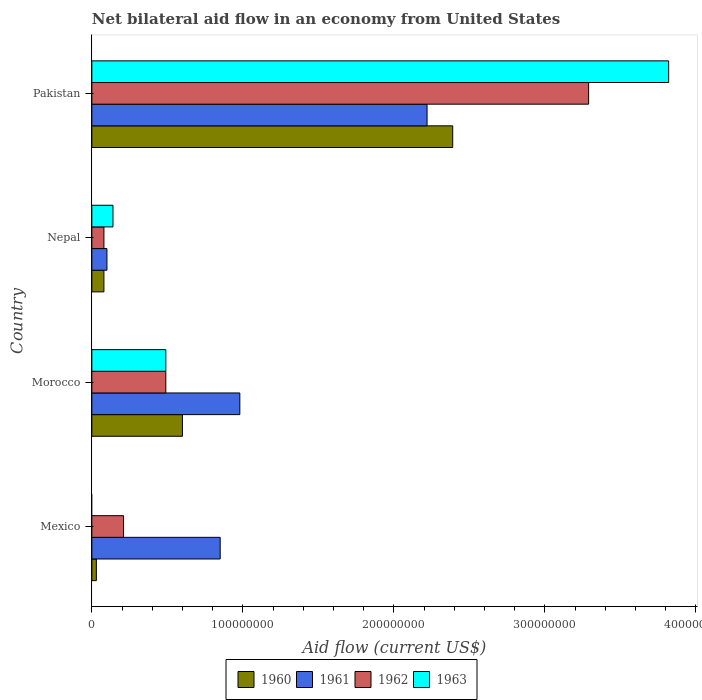How many different coloured bars are there?
Provide a succinct answer. 4. How many bars are there on the 3rd tick from the top?
Your answer should be compact. 4. What is the label of the 2nd group of bars from the top?
Your answer should be very brief. Nepal. In how many cases, is the number of bars for a given country not equal to the number of legend labels?
Your answer should be compact. 1. Across all countries, what is the maximum net bilateral aid flow in 1963?
Provide a short and direct response. 3.82e+08. Across all countries, what is the minimum net bilateral aid flow in 1961?
Keep it short and to the point. 1.00e+07. What is the total net bilateral aid flow in 1961 in the graph?
Provide a short and direct response. 4.15e+08. What is the difference between the net bilateral aid flow in 1960 in Morocco and that in Pakistan?
Your answer should be very brief. -1.79e+08. What is the difference between the net bilateral aid flow in 1960 in Morocco and the net bilateral aid flow in 1962 in Mexico?
Provide a succinct answer. 3.90e+07. What is the average net bilateral aid flow in 1963 per country?
Provide a succinct answer. 1.11e+08. What is the difference between the net bilateral aid flow in 1960 and net bilateral aid flow in 1962 in Morocco?
Give a very brief answer. 1.10e+07. What is the ratio of the net bilateral aid flow in 1962 in Morocco to that in Nepal?
Offer a very short reply. 6.12. What is the difference between the highest and the second highest net bilateral aid flow in 1960?
Your response must be concise. 1.79e+08. What is the difference between the highest and the lowest net bilateral aid flow in 1962?
Provide a succinct answer. 3.21e+08. In how many countries, is the net bilateral aid flow in 1960 greater than the average net bilateral aid flow in 1960 taken over all countries?
Make the answer very short. 1. Is it the case that in every country, the sum of the net bilateral aid flow in 1961 and net bilateral aid flow in 1960 is greater than the sum of net bilateral aid flow in 1963 and net bilateral aid flow in 1962?
Ensure brevity in your answer.  No. Is it the case that in every country, the sum of the net bilateral aid flow in 1963 and net bilateral aid flow in 1961 is greater than the net bilateral aid flow in 1960?
Provide a short and direct response. Yes. How many countries are there in the graph?
Provide a succinct answer. 4. Are the values on the major ticks of X-axis written in scientific E-notation?
Offer a terse response. No. Does the graph contain grids?
Keep it short and to the point. No. How many legend labels are there?
Keep it short and to the point. 4. How are the legend labels stacked?
Your response must be concise. Horizontal. What is the title of the graph?
Offer a very short reply. Net bilateral aid flow in an economy from United States. What is the label or title of the Y-axis?
Make the answer very short. Country. What is the Aid flow (current US$) of 1961 in Mexico?
Make the answer very short. 8.50e+07. What is the Aid flow (current US$) of 1962 in Mexico?
Keep it short and to the point. 2.10e+07. What is the Aid flow (current US$) of 1963 in Mexico?
Ensure brevity in your answer.  0. What is the Aid flow (current US$) of 1960 in Morocco?
Make the answer very short. 6.00e+07. What is the Aid flow (current US$) of 1961 in Morocco?
Give a very brief answer. 9.80e+07. What is the Aid flow (current US$) in 1962 in Morocco?
Offer a very short reply. 4.90e+07. What is the Aid flow (current US$) in 1963 in Morocco?
Provide a succinct answer. 4.90e+07. What is the Aid flow (current US$) of 1960 in Nepal?
Provide a short and direct response. 8.00e+06. What is the Aid flow (current US$) of 1961 in Nepal?
Provide a short and direct response. 1.00e+07. What is the Aid flow (current US$) in 1962 in Nepal?
Keep it short and to the point. 8.00e+06. What is the Aid flow (current US$) in 1963 in Nepal?
Ensure brevity in your answer.  1.40e+07. What is the Aid flow (current US$) of 1960 in Pakistan?
Your answer should be very brief. 2.39e+08. What is the Aid flow (current US$) of 1961 in Pakistan?
Your answer should be compact. 2.22e+08. What is the Aid flow (current US$) of 1962 in Pakistan?
Ensure brevity in your answer.  3.29e+08. What is the Aid flow (current US$) of 1963 in Pakistan?
Provide a succinct answer. 3.82e+08. Across all countries, what is the maximum Aid flow (current US$) of 1960?
Your answer should be very brief. 2.39e+08. Across all countries, what is the maximum Aid flow (current US$) of 1961?
Give a very brief answer. 2.22e+08. Across all countries, what is the maximum Aid flow (current US$) in 1962?
Provide a short and direct response. 3.29e+08. Across all countries, what is the maximum Aid flow (current US$) of 1963?
Your answer should be very brief. 3.82e+08. Across all countries, what is the minimum Aid flow (current US$) in 1961?
Give a very brief answer. 1.00e+07. What is the total Aid flow (current US$) of 1960 in the graph?
Your response must be concise. 3.10e+08. What is the total Aid flow (current US$) of 1961 in the graph?
Give a very brief answer. 4.15e+08. What is the total Aid flow (current US$) in 1962 in the graph?
Your answer should be very brief. 4.07e+08. What is the total Aid flow (current US$) of 1963 in the graph?
Provide a short and direct response. 4.45e+08. What is the difference between the Aid flow (current US$) of 1960 in Mexico and that in Morocco?
Ensure brevity in your answer.  -5.70e+07. What is the difference between the Aid flow (current US$) in 1961 in Mexico and that in Morocco?
Provide a succinct answer. -1.30e+07. What is the difference between the Aid flow (current US$) of 1962 in Mexico and that in Morocco?
Your answer should be compact. -2.80e+07. What is the difference between the Aid flow (current US$) in 1960 in Mexico and that in Nepal?
Your answer should be compact. -5.00e+06. What is the difference between the Aid flow (current US$) of 1961 in Mexico and that in Nepal?
Your answer should be very brief. 7.50e+07. What is the difference between the Aid flow (current US$) of 1962 in Mexico and that in Nepal?
Make the answer very short. 1.30e+07. What is the difference between the Aid flow (current US$) in 1960 in Mexico and that in Pakistan?
Provide a short and direct response. -2.36e+08. What is the difference between the Aid flow (current US$) in 1961 in Mexico and that in Pakistan?
Your answer should be compact. -1.37e+08. What is the difference between the Aid flow (current US$) in 1962 in Mexico and that in Pakistan?
Your answer should be very brief. -3.08e+08. What is the difference between the Aid flow (current US$) in 1960 in Morocco and that in Nepal?
Offer a terse response. 5.20e+07. What is the difference between the Aid flow (current US$) of 1961 in Morocco and that in Nepal?
Provide a short and direct response. 8.80e+07. What is the difference between the Aid flow (current US$) in 1962 in Morocco and that in Nepal?
Your response must be concise. 4.10e+07. What is the difference between the Aid flow (current US$) of 1963 in Morocco and that in Nepal?
Offer a terse response. 3.50e+07. What is the difference between the Aid flow (current US$) in 1960 in Morocco and that in Pakistan?
Give a very brief answer. -1.79e+08. What is the difference between the Aid flow (current US$) of 1961 in Morocco and that in Pakistan?
Offer a very short reply. -1.24e+08. What is the difference between the Aid flow (current US$) of 1962 in Morocco and that in Pakistan?
Ensure brevity in your answer.  -2.80e+08. What is the difference between the Aid flow (current US$) of 1963 in Morocco and that in Pakistan?
Make the answer very short. -3.33e+08. What is the difference between the Aid flow (current US$) in 1960 in Nepal and that in Pakistan?
Your answer should be compact. -2.31e+08. What is the difference between the Aid flow (current US$) of 1961 in Nepal and that in Pakistan?
Your answer should be compact. -2.12e+08. What is the difference between the Aid flow (current US$) in 1962 in Nepal and that in Pakistan?
Provide a succinct answer. -3.21e+08. What is the difference between the Aid flow (current US$) of 1963 in Nepal and that in Pakistan?
Your answer should be compact. -3.68e+08. What is the difference between the Aid flow (current US$) in 1960 in Mexico and the Aid flow (current US$) in 1961 in Morocco?
Your response must be concise. -9.50e+07. What is the difference between the Aid flow (current US$) of 1960 in Mexico and the Aid flow (current US$) of 1962 in Morocco?
Your answer should be compact. -4.60e+07. What is the difference between the Aid flow (current US$) in 1960 in Mexico and the Aid flow (current US$) in 1963 in Morocco?
Ensure brevity in your answer.  -4.60e+07. What is the difference between the Aid flow (current US$) of 1961 in Mexico and the Aid flow (current US$) of 1962 in Morocco?
Ensure brevity in your answer.  3.60e+07. What is the difference between the Aid flow (current US$) of 1961 in Mexico and the Aid flow (current US$) of 1963 in Morocco?
Ensure brevity in your answer.  3.60e+07. What is the difference between the Aid flow (current US$) in 1962 in Mexico and the Aid flow (current US$) in 1963 in Morocco?
Make the answer very short. -2.80e+07. What is the difference between the Aid flow (current US$) of 1960 in Mexico and the Aid flow (current US$) of 1961 in Nepal?
Keep it short and to the point. -7.00e+06. What is the difference between the Aid flow (current US$) in 1960 in Mexico and the Aid flow (current US$) in 1962 in Nepal?
Give a very brief answer. -5.00e+06. What is the difference between the Aid flow (current US$) in 1960 in Mexico and the Aid flow (current US$) in 1963 in Nepal?
Ensure brevity in your answer.  -1.10e+07. What is the difference between the Aid flow (current US$) in 1961 in Mexico and the Aid flow (current US$) in 1962 in Nepal?
Your answer should be compact. 7.70e+07. What is the difference between the Aid flow (current US$) of 1961 in Mexico and the Aid flow (current US$) of 1963 in Nepal?
Ensure brevity in your answer.  7.10e+07. What is the difference between the Aid flow (current US$) in 1960 in Mexico and the Aid flow (current US$) in 1961 in Pakistan?
Keep it short and to the point. -2.19e+08. What is the difference between the Aid flow (current US$) in 1960 in Mexico and the Aid flow (current US$) in 1962 in Pakistan?
Your response must be concise. -3.26e+08. What is the difference between the Aid flow (current US$) of 1960 in Mexico and the Aid flow (current US$) of 1963 in Pakistan?
Make the answer very short. -3.79e+08. What is the difference between the Aid flow (current US$) of 1961 in Mexico and the Aid flow (current US$) of 1962 in Pakistan?
Keep it short and to the point. -2.44e+08. What is the difference between the Aid flow (current US$) of 1961 in Mexico and the Aid flow (current US$) of 1963 in Pakistan?
Ensure brevity in your answer.  -2.97e+08. What is the difference between the Aid flow (current US$) of 1962 in Mexico and the Aid flow (current US$) of 1963 in Pakistan?
Provide a short and direct response. -3.61e+08. What is the difference between the Aid flow (current US$) in 1960 in Morocco and the Aid flow (current US$) in 1962 in Nepal?
Provide a short and direct response. 5.20e+07. What is the difference between the Aid flow (current US$) of 1960 in Morocco and the Aid flow (current US$) of 1963 in Nepal?
Provide a short and direct response. 4.60e+07. What is the difference between the Aid flow (current US$) in 1961 in Morocco and the Aid flow (current US$) in 1962 in Nepal?
Provide a succinct answer. 9.00e+07. What is the difference between the Aid flow (current US$) of 1961 in Morocco and the Aid flow (current US$) of 1963 in Nepal?
Give a very brief answer. 8.40e+07. What is the difference between the Aid flow (current US$) of 1962 in Morocco and the Aid flow (current US$) of 1963 in Nepal?
Offer a very short reply. 3.50e+07. What is the difference between the Aid flow (current US$) of 1960 in Morocco and the Aid flow (current US$) of 1961 in Pakistan?
Provide a short and direct response. -1.62e+08. What is the difference between the Aid flow (current US$) in 1960 in Morocco and the Aid flow (current US$) in 1962 in Pakistan?
Your response must be concise. -2.69e+08. What is the difference between the Aid flow (current US$) of 1960 in Morocco and the Aid flow (current US$) of 1963 in Pakistan?
Offer a terse response. -3.22e+08. What is the difference between the Aid flow (current US$) in 1961 in Morocco and the Aid flow (current US$) in 1962 in Pakistan?
Provide a short and direct response. -2.31e+08. What is the difference between the Aid flow (current US$) in 1961 in Morocco and the Aid flow (current US$) in 1963 in Pakistan?
Keep it short and to the point. -2.84e+08. What is the difference between the Aid flow (current US$) of 1962 in Morocco and the Aid flow (current US$) of 1963 in Pakistan?
Keep it short and to the point. -3.33e+08. What is the difference between the Aid flow (current US$) of 1960 in Nepal and the Aid flow (current US$) of 1961 in Pakistan?
Give a very brief answer. -2.14e+08. What is the difference between the Aid flow (current US$) in 1960 in Nepal and the Aid flow (current US$) in 1962 in Pakistan?
Make the answer very short. -3.21e+08. What is the difference between the Aid flow (current US$) of 1960 in Nepal and the Aid flow (current US$) of 1963 in Pakistan?
Make the answer very short. -3.74e+08. What is the difference between the Aid flow (current US$) of 1961 in Nepal and the Aid flow (current US$) of 1962 in Pakistan?
Offer a terse response. -3.19e+08. What is the difference between the Aid flow (current US$) in 1961 in Nepal and the Aid flow (current US$) in 1963 in Pakistan?
Offer a very short reply. -3.72e+08. What is the difference between the Aid flow (current US$) in 1962 in Nepal and the Aid flow (current US$) in 1963 in Pakistan?
Provide a succinct answer. -3.74e+08. What is the average Aid flow (current US$) in 1960 per country?
Your answer should be compact. 7.75e+07. What is the average Aid flow (current US$) of 1961 per country?
Offer a terse response. 1.04e+08. What is the average Aid flow (current US$) of 1962 per country?
Offer a very short reply. 1.02e+08. What is the average Aid flow (current US$) in 1963 per country?
Provide a short and direct response. 1.11e+08. What is the difference between the Aid flow (current US$) in 1960 and Aid flow (current US$) in 1961 in Mexico?
Your response must be concise. -8.20e+07. What is the difference between the Aid flow (current US$) of 1960 and Aid flow (current US$) of 1962 in Mexico?
Offer a very short reply. -1.80e+07. What is the difference between the Aid flow (current US$) of 1961 and Aid flow (current US$) of 1962 in Mexico?
Your response must be concise. 6.40e+07. What is the difference between the Aid flow (current US$) in 1960 and Aid flow (current US$) in 1961 in Morocco?
Give a very brief answer. -3.80e+07. What is the difference between the Aid flow (current US$) of 1960 and Aid flow (current US$) of 1962 in Morocco?
Keep it short and to the point. 1.10e+07. What is the difference between the Aid flow (current US$) in 1960 and Aid flow (current US$) in 1963 in Morocco?
Give a very brief answer. 1.10e+07. What is the difference between the Aid flow (current US$) in 1961 and Aid flow (current US$) in 1962 in Morocco?
Ensure brevity in your answer.  4.90e+07. What is the difference between the Aid flow (current US$) of 1961 and Aid flow (current US$) of 1963 in Morocco?
Offer a very short reply. 4.90e+07. What is the difference between the Aid flow (current US$) in 1962 and Aid flow (current US$) in 1963 in Morocco?
Ensure brevity in your answer.  0. What is the difference between the Aid flow (current US$) in 1960 and Aid flow (current US$) in 1961 in Nepal?
Offer a very short reply. -2.00e+06. What is the difference between the Aid flow (current US$) of 1960 and Aid flow (current US$) of 1962 in Nepal?
Your answer should be very brief. 0. What is the difference between the Aid flow (current US$) in 1960 and Aid flow (current US$) in 1963 in Nepal?
Your response must be concise. -6.00e+06. What is the difference between the Aid flow (current US$) in 1961 and Aid flow (current US$) in 1962 in Nepal?
Offer a terse response. 2.00e+06. What is the difference between the Aid flow (current US$) in 1961 and Aid flow (current US$) in 1963 in Nepal?
Make the answer very short. -4.00e+06. What is the difference between the Aid flow (current US$) in 1962 and Aid flow (current US$) in 1963 in Nepal?
Give a very brief answer. -6.00e+06. What is the difference between the Aid flow (current US$) of 1960 and Aid flow (current US$) of 1961 in Pakistan?
Make the answer very short. 1.70e+07. What is the difference between the Aid flow (current US$) in 1960 and Aid flow (current US$) in 1962 in Pakistan?
Provide a succinct answer. -9.00e+07. What is the difference between the Aid flow (current US$) in 1960 and Aid flow (current US$) in 1963 in Pakistan?
Provide a short and direct response. -1.43e+08. What is the difference between the Aid flow (current US$) of 1961 and Aid flow (current US$) of 1962 in Pakistan?
Ensure brevity in your answer.  -1.07e+08. What is the difference between the Aid flow (current US$) in 1961 and Aid flow (current US$) in 1963 in Pakistan?
Offer a very short reply. -1.60e+08. What is the difference between the Aid flow (current US$) of 1962 and Aid flow (current US$) of 1963 in Pakistan?
Ensure brevity in your answer.  -5.30e+07. What is the ratio of the Aid flow (current US$) of 1960 in Mexico to that in Morocco?
Provide a short and direct response. 0.05. What is the ratio of the Aid flow (current US$) of 1961 in Mexico to that in Morocco?
Your answer should be very brief. 0.87. What is the ratio of the Aid flow (current US$) in 1962 in Mexico to that in Morocco?
Give a very brief answer. 0.43. What is the ratio of the Aid flow (current US$) of 1962 in Mexico to that in Nepal?
Offer a very short reply. 2.62. What is the ratio of the Aid flow (current US$) of 1960 in Mexico to that in Pakistan?
Offer a terse response. 0.01. What is the ratio of the Aid flow (current US$) of 1961 in Mexico to that in Pakistan?
Your answer should be compact. 0.38. What is the ratio of the Aid flow (current US$) in 1962 in Mexico to that in Pakistan?
Provide a succinct answer. 0.06. What is the ratio of the Aid flow (current US$) in 1962 in Morocco to that in Nepal?
Your answer should be very brief. 6.12. What is the ratio of the Aid flow (current US$) in 1960 in Morocco to that in Pakistan?
Give a very brief answer. 0.25. What is the ratio of the Aid flow (current US$) in 1961 in Morocco to that in Pakistan?
Give a very brief answer. 0.44. What is the ratio of the Aid flow (current US$) of 1962 in Morocco to that in Pakistan?
Make the answer very short. 0.15. What is the ratio of the Aid flow (current US$) of 1963 in Morocco to that in Pakistan?
Offer a very short reply. 0.13. What is the ratio of the Aid flow (current US$) in 1960 in Nepal to that in Pakistan?
Your answer should be compact. 0.03. What is the ratio of the Aid flow (current US$) of 1961 in Nepal to that in Pakistan?
Your response must be concise. 0.04. What is the ratio of the Aid flow (current US$) of 1962 in Nepal to that in Pakistan?
Provide a short and direct response. 0.02. What is the ratio of the Aid flow (current US$) of 1963 in Nepal to that in Pakistan?
Your response must be concise. 0.04. What is the difference between the highest and the second highest Aid flow (current US$) in 1960?
Provide a short and direct response. 1.79e+08. What is the difference between the highest and the second highest Aid flow (current US$) of 1961?
Provide a short and direct response. 1.24e+08. What is the difference between the highest and the second highest Aid flow (current US$) in 1962?
Keep it short and to the point. 2.80e+08. What is the difference between the highest and the second highest Aid flow (current US$) of 1963?
Your answer should be very brief. 3.33e+08. What is the difference between the highest and the lowest Aid flow (current US$) of 1960?
Offer a terse response. 2.36e+08. What is the difference between the highest and the lowest Aid flow (current US$) of 1961?
Offer a very short reply. 2.12e+08. What is the difference between the highest and the lowest Aid flow (current US$) in 1962?
Offer a terse response. 3.21e+08. What is the difference between the highest and the lowest Aid flow (current US$) of 1963?
Ensure brevity in your answer.  3.82e+08. 